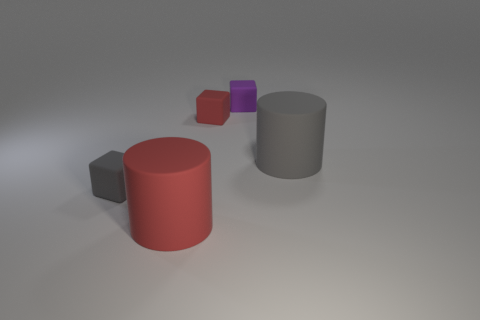There is a object that is both to the right of the tiny red thing and to the left of the large gray cylinder; what size is it?
Your answer should be very brief. Small. Are there any purple rubber blocks?
Your answer should be compact. Yes. How many other things are the same size as the red cube?
Ensure brevity in your answer.  2. Do the cylinder to the right of the large red thing and the small cube to the left of the large red matte thing have the same color?
Your answer should be compact. Yes. What is the size of the gray object that is the same shape as the tiny red thing?
Offer a terse response. Small. Is the big cylinder to the left of the purple matte cube made of the same material as the big object that is behind the gray matte cube?
Give a very brief answer. Yes. What number of matte things are tiny gray spheres or red cylinders?
Your answer should be compact. 1. What material is the large red object that is in front of the small block that is left of the big cylinder to the left of the tiny purple rubber thing?
Offer a very short reply. Rubber. Does the gray object on the left side of the purple object have the same shape as the big object right of the tiny red rubber object?
Your answer should be compact. No. There is a cylinder behind the big matte cylinder that is in front of the tiny gray rubber block; what is its color?
Offer a very short reply. Gray. 